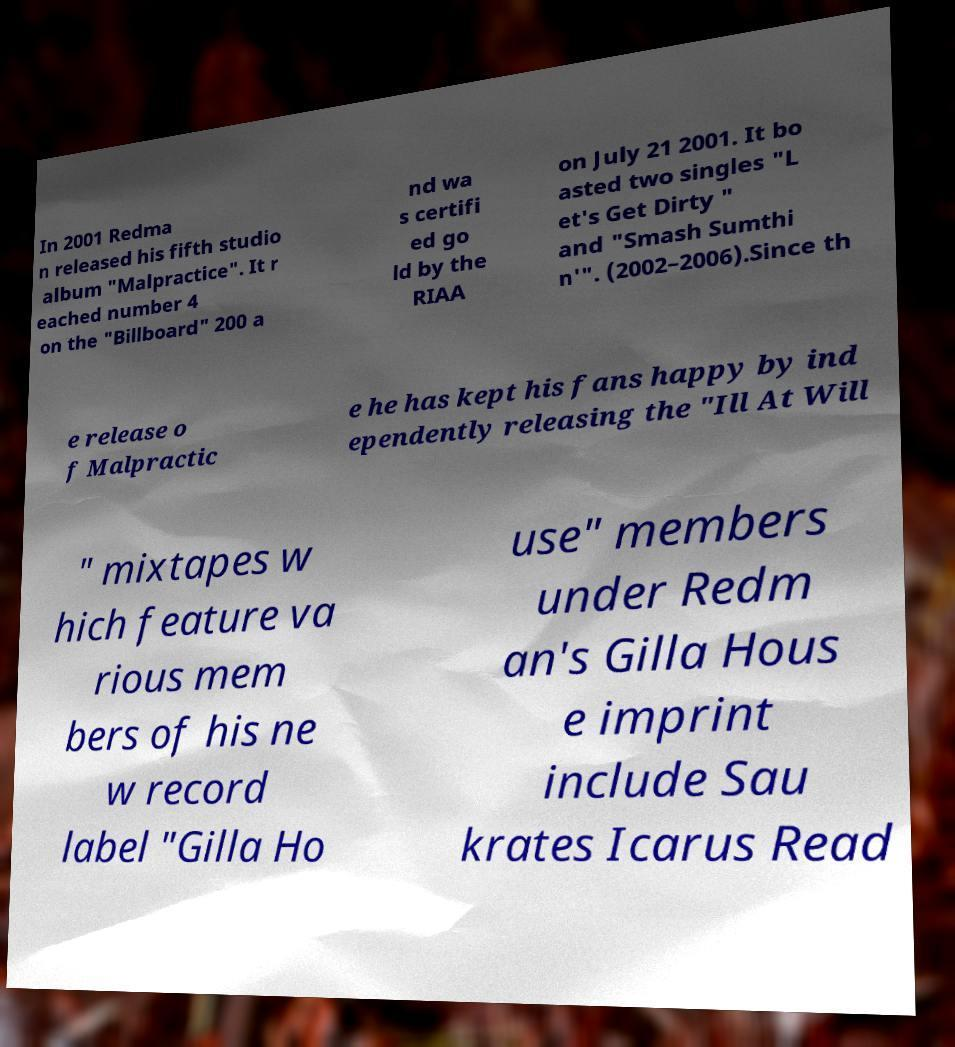I need the written content from this picture converted into text. Can you do that? In 2001 Redma n released his fifth studio album "Malpractice". It r eached number 4 on the "Billboard" 200 a nd wa s certifi ed go ld by the RIAA on July 21 2001. It bo asted two singles "L et's Get Dirty " and "Smash Sumthi n'". (2002–2006).Since th e release o f Malpractic e he has kept his fans happy by ind ependently releasing the "Ill At Will " mixtapes w hich feature va rious mem bers of his ne w record label "Gilla Ho use" members under Redm an's Gilla Hous e imprint include Sau krates Icarus Read 